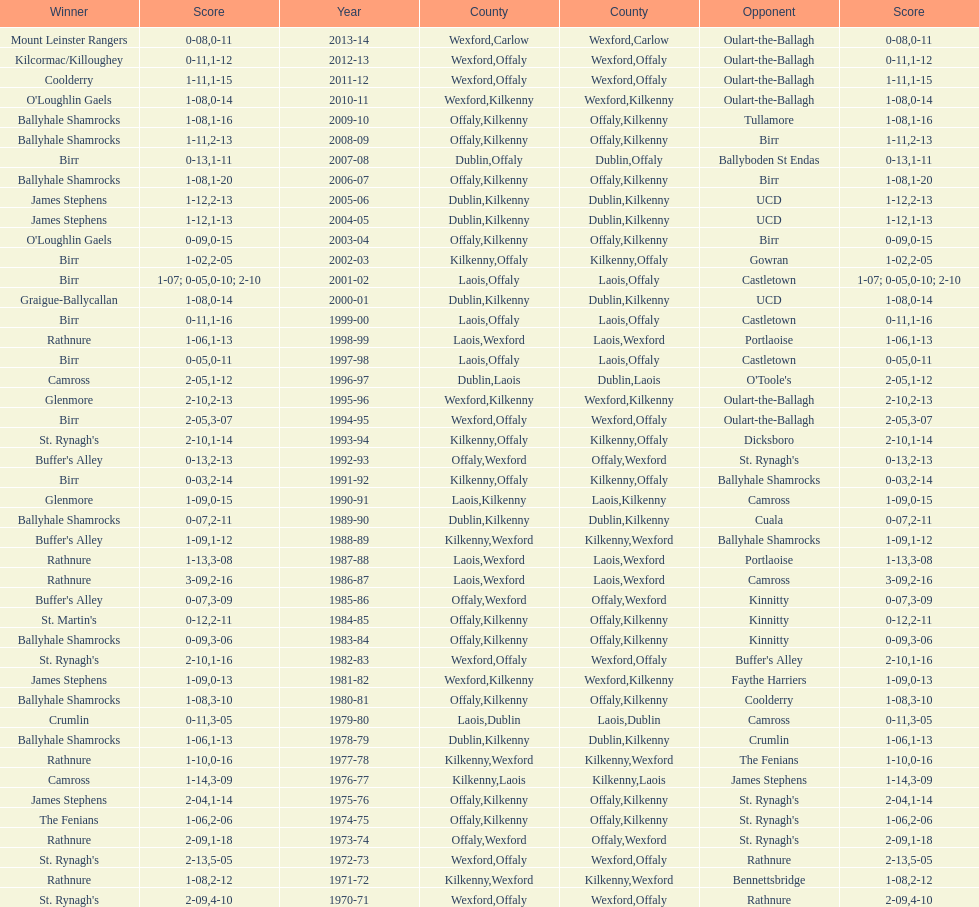How many consecutive years did rathnure win? 2. 